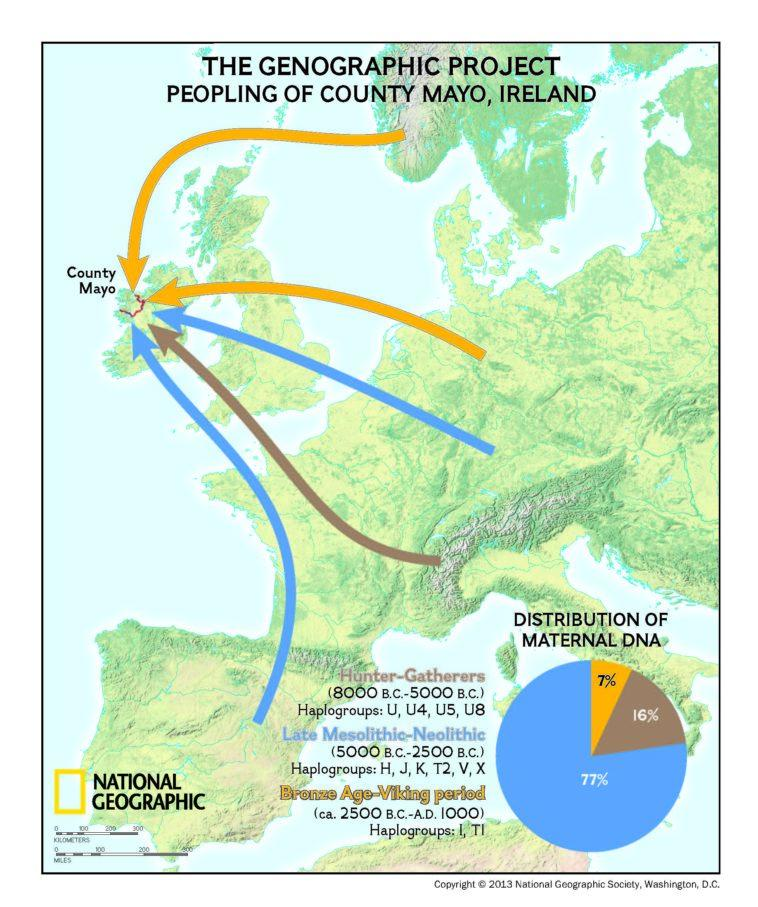List a handful of essential elements in this visual. Approximately 77% of the maternal DNA found in County Mayo, Ireland, can be traced back to the Late Mesolithic-Neolithic period. In County Mayo of Ireland, approximately 16% of the maternal DNA is from hunter-gatherers. 